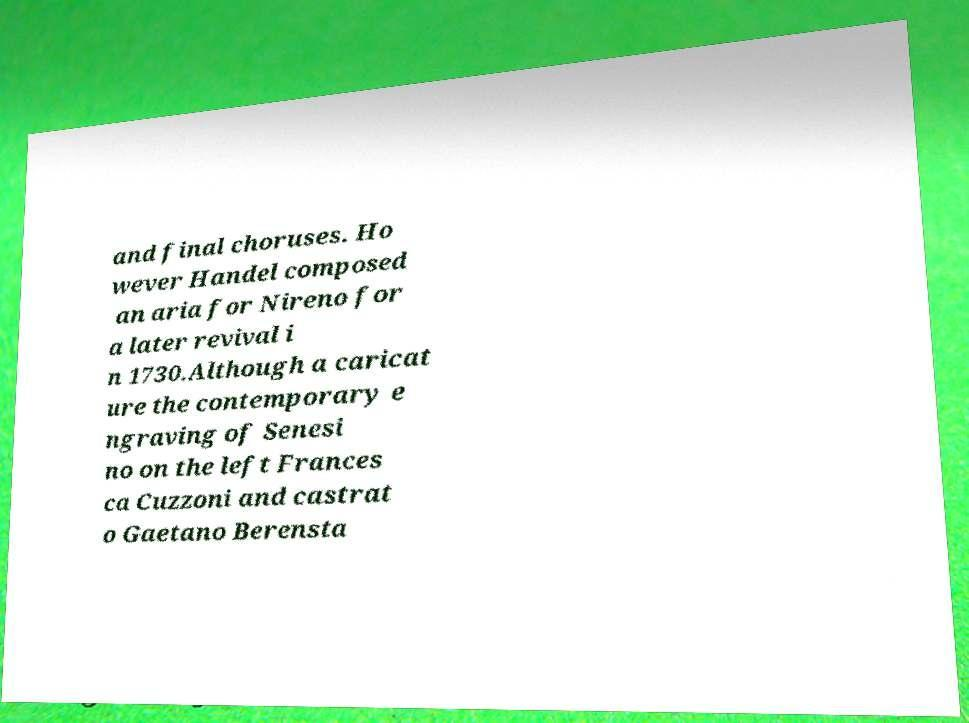I need the written content from this picture converted into text. Can you do that? and final choruses. Ho wever Handel composed an aria for Nireno for a later revival i n 1730.Although a caricat ure the contemporary e ngraving of Senesi no on the left Frances ca Cuzzoni and castrat o Gaetano Berensta 